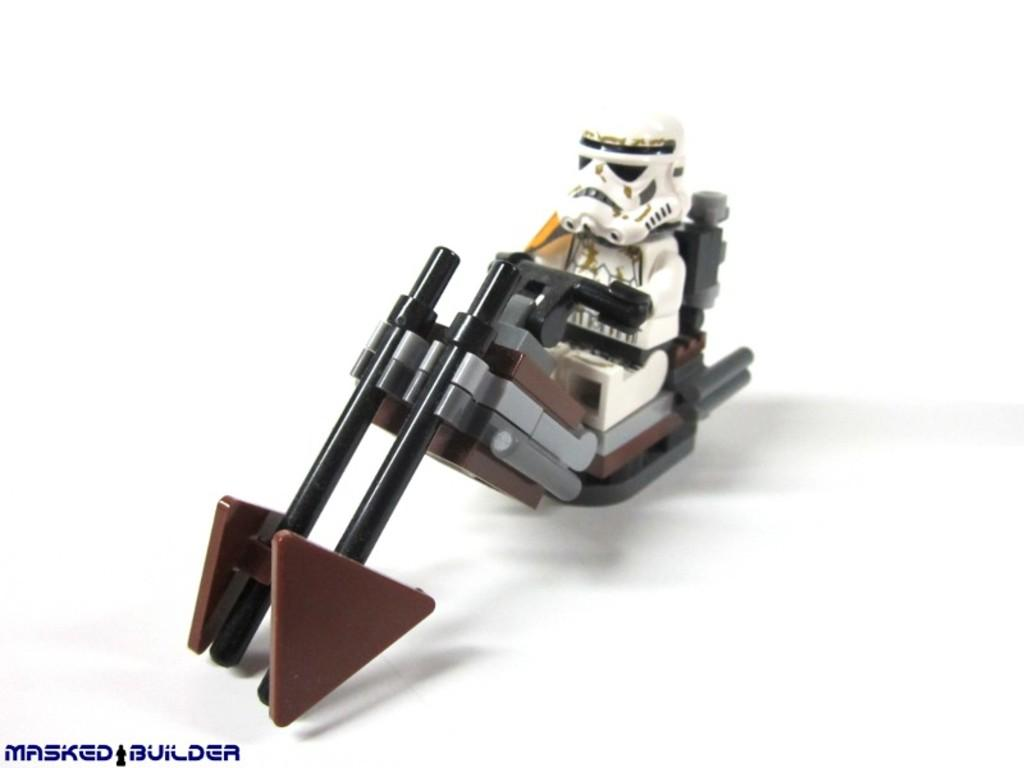What is the main subject of the image? The image appears to depict a toy. What color is the background of the image? The background of the image is white. Is there any additional information or branding on the image? Yes, there is a watermark on the image. What acoustics can be heard from the toy in the image? There is no sound or acoustics present in the image, as it is a still image of a toy. What rule is being enforced by the toy in the image? There is no rule being enforced by the toy in the image, as it is an inanimate object. 